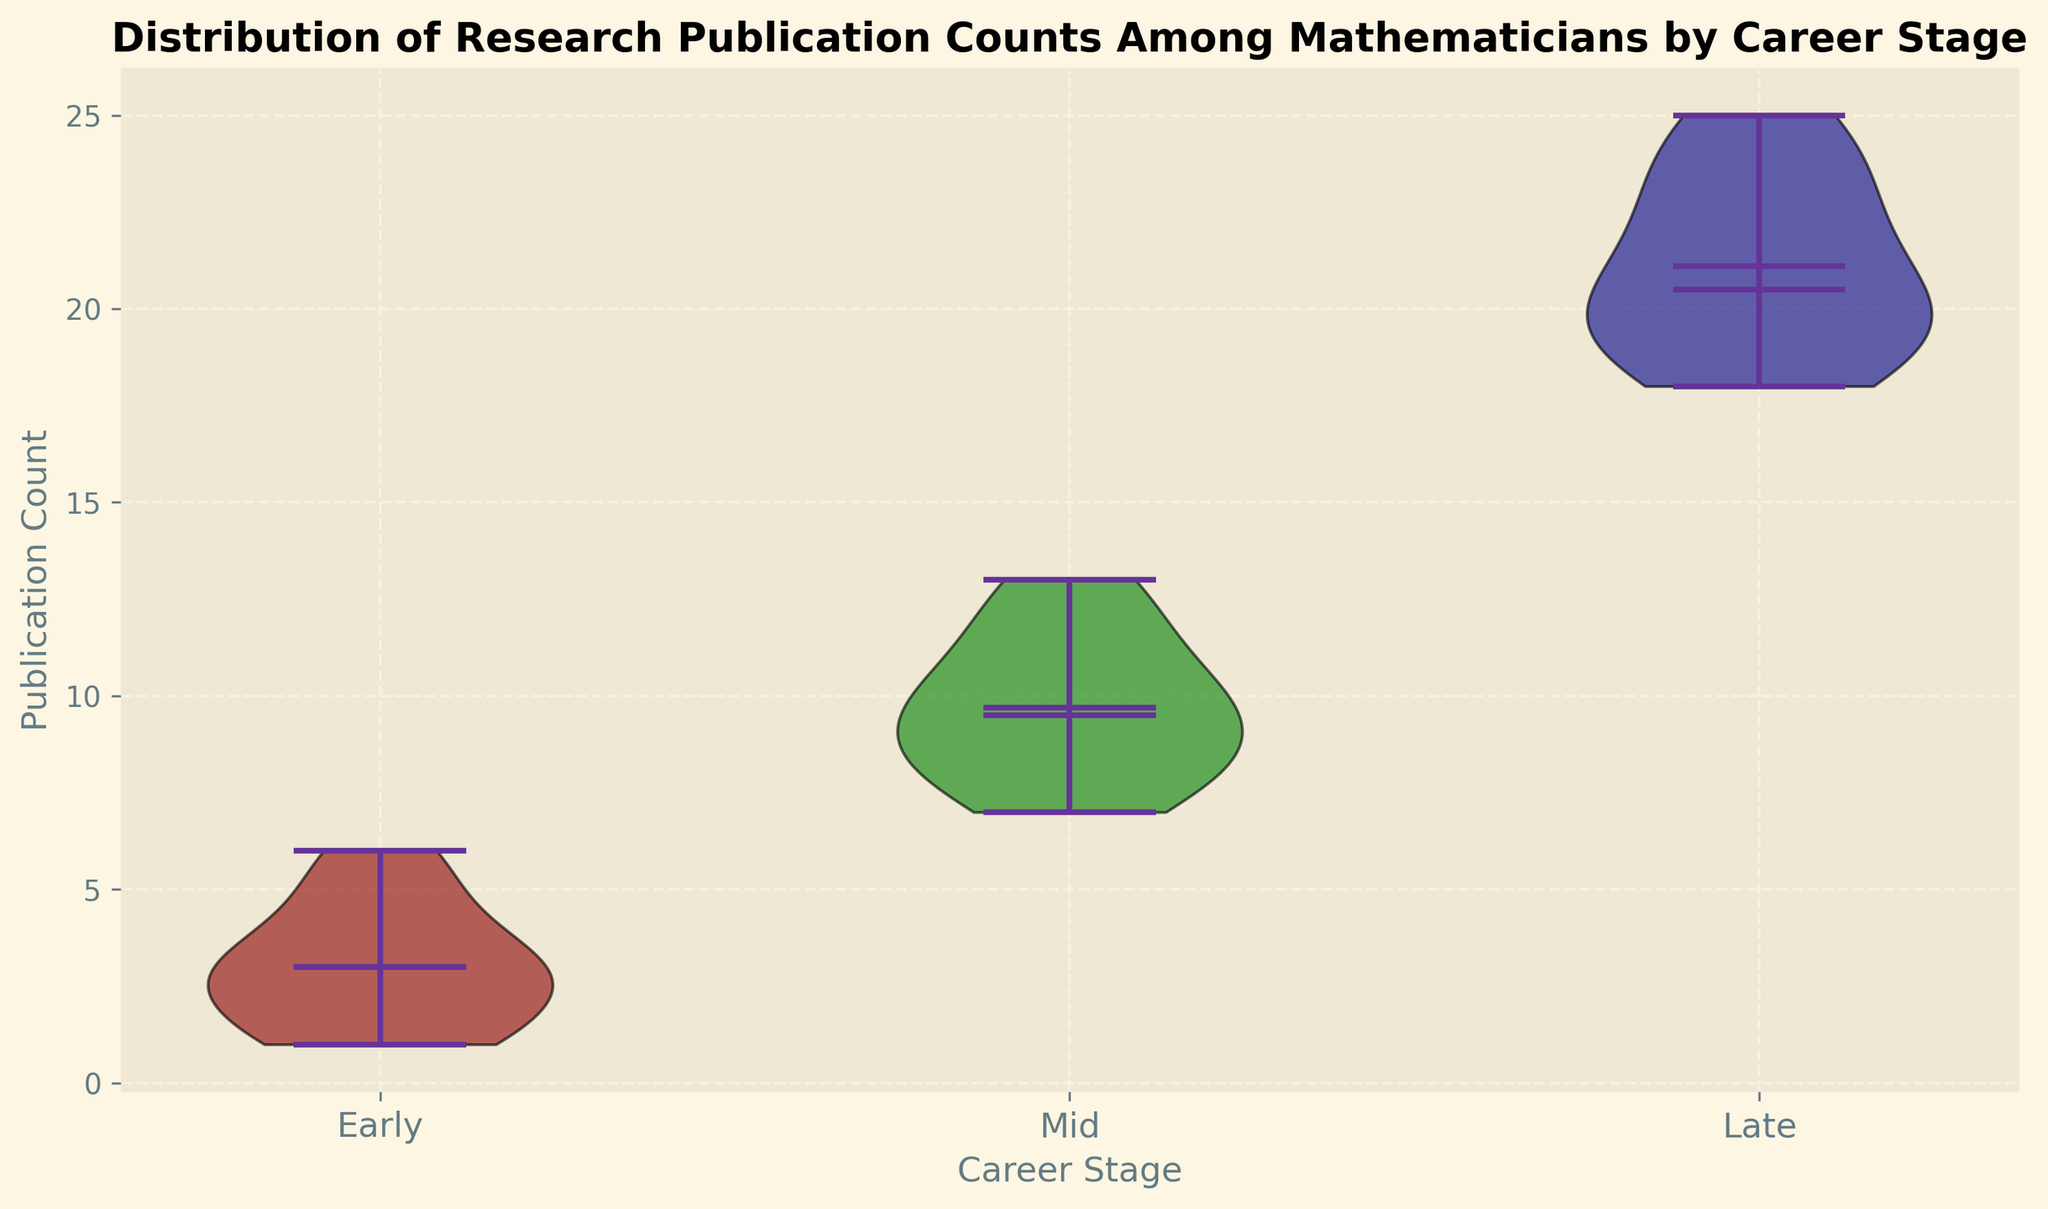How do the median publication counts compare among the different career stages? The median publication count for each career stage can be determined by the position of the median line within each violin plot. Early-stage median is around 3, mid-stage median is around 9, and late-stage median is around 20. Thus, the median publication counts increase as career stage progresses from early to mid to late stage.
Answer: Medians: Early: 3, Mid: 9, Late: 20 Which career stage has the greatest range of publication counts? The range can be assessed by the distance between the minimum and maximum lines within each violin plot. For the early career, the range is 1 to 6 (range = 5), for mid-career it is 7 to 13 (range = 6), and for late-career it is 18 to 25 (range = 7). Since 7 is the largest range, late stage has the greatest range of publication counts.
Answer: Late stage Are the publication counts of mid-stage career mathematicians generally higher than those of early-stage career mathematicians? Comparing the two violin plots visually, the entire range of mid-stage publication counts (7-13) is higher than the entire range of early-stage publication counts (1-6). Therefore, yes, the publication counts of mid-stage career mathematicians are generally higher than those of early-stage career mathematicians.
Answer: Yes What is the mean publication count for early-stage career mathematicians as indicated in the plot? The mean publication count is indicated by the position of the dot within the violin plot. For early-stage career mathematicians, the mean appears to be around 3.
Answer: 3 Is the variability in publication counts for late-stage career mathematicians greater than that for mid-stage career mathematicians? Variability can be assessed by the width of the violin plot. For both stages, the plot is relatively narrow, but the late-stage plot appears slightly wider than the mid-stage plot, indicating more variability. Furthermore, the interquartile range (distance between the bottom 25% and top 25%) seems wider for the late stage.
Answer: Yes What is the color of the violin plot for mid-stage career mathematicians? The color indicates the stage; mid-stage career violin plot is green.
Answer: Green How does the mean publication count compare between early and mid-stage career mathematicians? The mean publication count is shown by the dot in the violin plots. The mean for early-stage is around 3, whereas for mid-stage it is around 10. Therefore, mid-stage career mathematicians have a higher mean publication count compared to early-stage career mathematicians.
Answer: Mid-stage is higher How does the maximum publication count for mid-stage career mathematicians compare to that of late-stage career mathematicians? The maximum publication count is indicated by the top line of each violin plot. For mid-stage career mathematicians, the maximum is 13, and for late-stage career mathematicians, it is 25. Therefore, the late stage has a higher maximum publication count.
Answer: Late stage is higher Are the mean and median publication counts the same for any of the career stages? By observing the position of the mean (dot) and the median (line) in each violin plot, we can see whether they align. They do not overlap for any of the stages; thus, the mean and median publication counts are not the same for any career stage.
Answer: No 